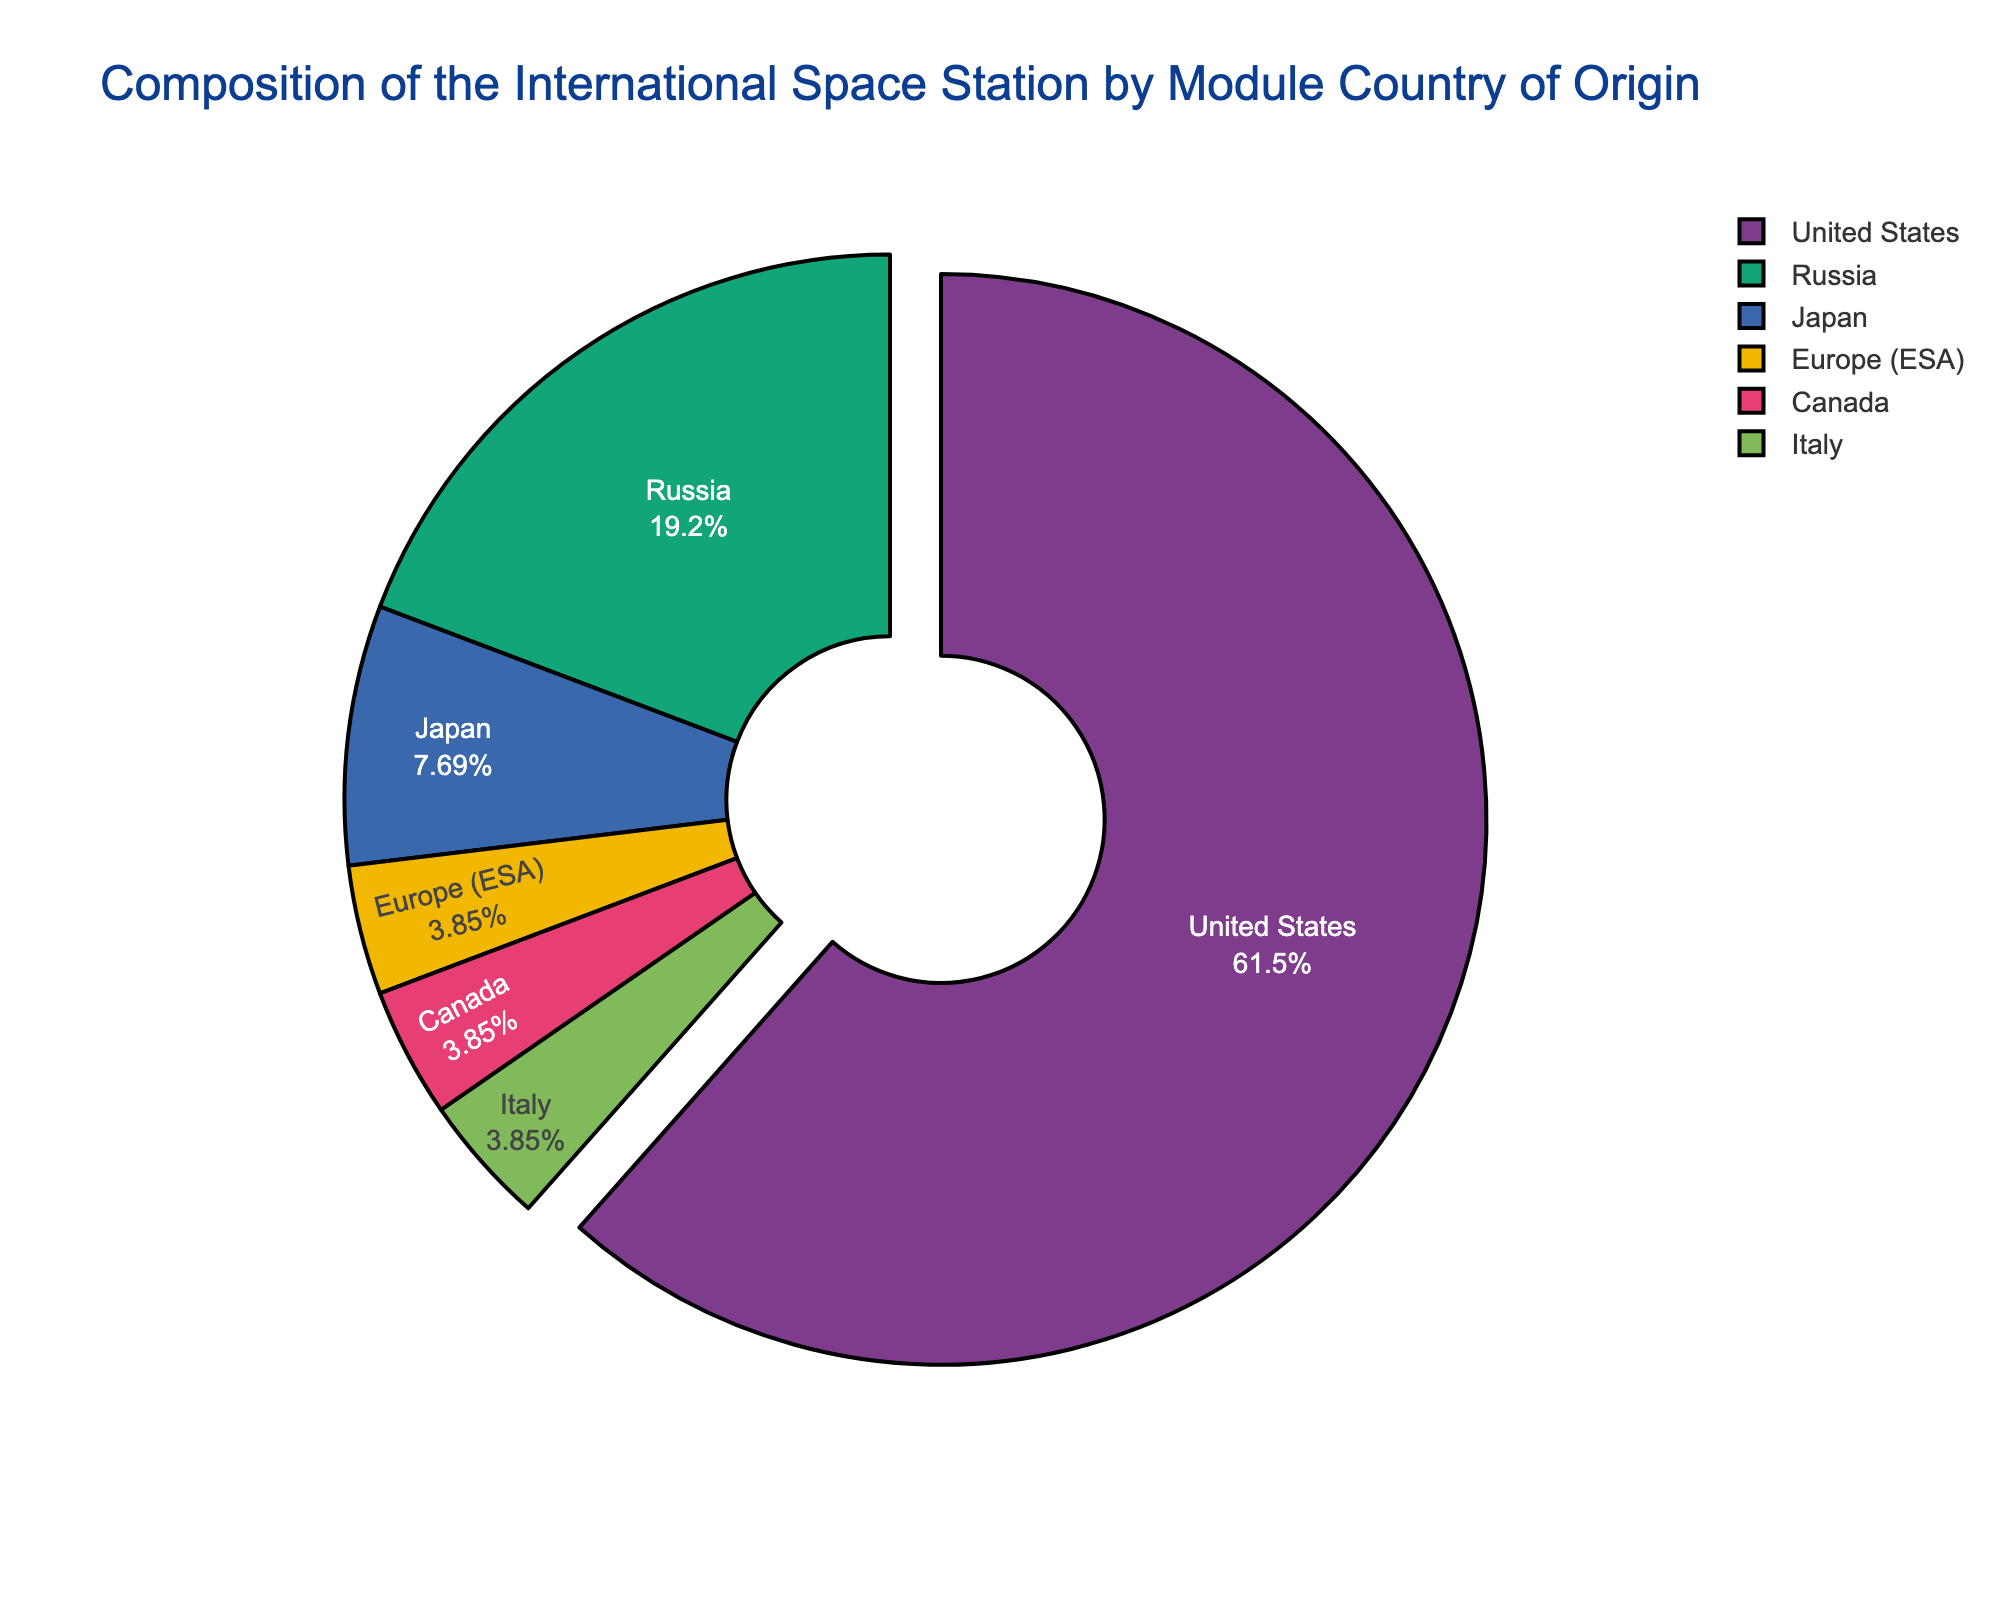What percentage of the total modules does the United States contribute? To find the percentage, divide the number of United States modules by the total number of modules, then multiply by 100. Total modules = 16 (US) + 5 (Russia) + 2 (Japan) + 1 (Europe) + 1 (Canada) + 1 (Italy) = 26. So, (16/26) * 100 ≈ 61.54%.
Answer: 61.54% Which country contributes the second highest number of modules? Looking at the figure, the United States contributes the most modules. Russia is listed next with 5 modules, which is the second highest.
Answer: Russia What is the combined percentage of modules from Japan, Europe, Canada, and Italy? Sum the modules from Japan, Europe, Canada, and Italy, then divide by the total number of modules and multiply by 100. Combined modules = 2 (Japan) + 1 (Europe) + 1 (Canada) + 1 (Italy) = 5. So, (5/26) * 100 ≈ 19.23%.
Answer: 19.23% How does the number of modules contributed by Japan compare to that contributed by Europe? Japan contributes 2 modules while Europe contributes 1 module, so Japan has twice as many modules as Europe.
Answer: Japan has twice as many modules as Europe Which country’s module contribution is equal to the combined contribution of Canada and Italy? Canada and Italy each contribute 1 module, so together they contribute 2 modules. Japan also contributes 2 modules, which is equal to the combined contribution of Canada and Italy.
Answer: Japan Which country is represented with the largest section in the pie chart? The largest section of the pie chart represents the United States, indicating it has the most modules.
Answer: United States What visual indication is used to highlight the contribution of the United States? The segment for the United States is slightly pulled out or separated from the rest of the pie chart segments to highlight it.
Answer: Segment pulled out Are there any countries that contribute the same number of modules? Yes, the European Space Agency, Canada, and Italy each contribute 1 module.
Answer: Europe (ESA), Canada, Italy What is the difference in the number of modules between the United States and Russia? The United States contributes 16 modules, while Russia contributes 5. Thus, the difference is 16 - 5 = 11 modules.
Answer: 11 modules What color is used to represent Japan's contribution in the pie chart? By visually inspecting the pie chart, the segment representing Japan's contribution is usually colored distinctly, often using a color such as green, red, or blue (the exact color would depend on the actual rendering but typically one of these primary distinct colors).
Answer: (Color will depend on rendered chart but typically green, red, or blue) 